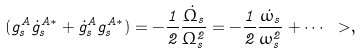<formula> <loc_0><loc_0><loc_500><loc_500>( g _ { s } ^ { A } \dot { g } _ { s } ^ { A \ast } + \dot { g } _ { s } ^ { A } g _ { s } ^ { A \ast } ) = - \frac { 1 } { 2 } \frac { \dot { \Omega } _ { s } } { \Omega _ { s } ^ { 2 } } = - \frac { 1 } { 2 } \frac { \dot { \omega } _ { s } } { \omega _ { s } ^ { 2 } } + \cdots \ > ,</formula> 